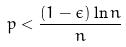<formula> <loc_0><loc_0><loc_500><loc_500>p < \frac { ( 1 - \epsilon ) \ln n } { n }</formula> 